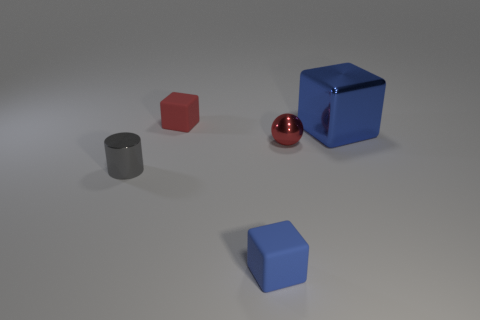Can you describe the relative positions of all the objects? Certainly! In the image, there are five objects positioned on a flat surface. Starting from the left, there is a small grey cylinder. Moving right, the next object is a small red cube. In line with the red cube and further back is a shiny red sphere. To the right of the sphere and slightly in front of it, there's a large blue cube with a high-gloss finish. Finally, in front of this blue cube and slightly to its right, there's a smaller blue matte cube. 